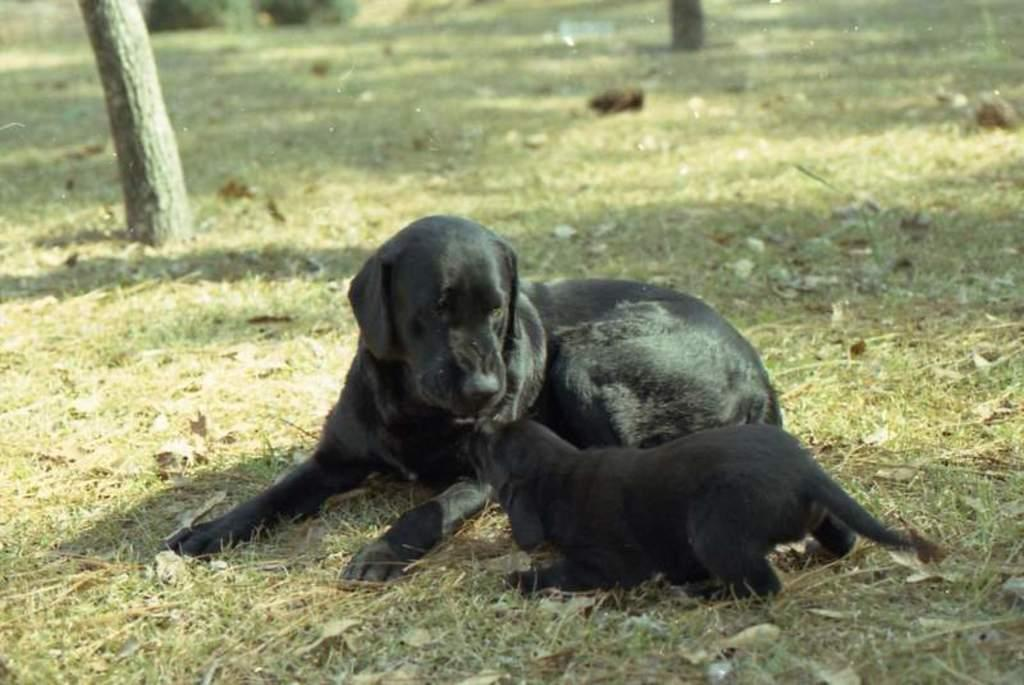What type of animal is in the image? There is a black dog in the image. What is the dog doing in the image? The dog is sitting on the ground. Is there another dog in the image? Yes, there is a black puppy in the image. Where is the puppy located in relation to the dog? The puppy is in front of the dog. What is the ground covered with in the image? The ground is covered with grass. What is the dog's desire to do with its finger in the image? There is no mention of a finger in the image, and the dog's desires are not depicted. 